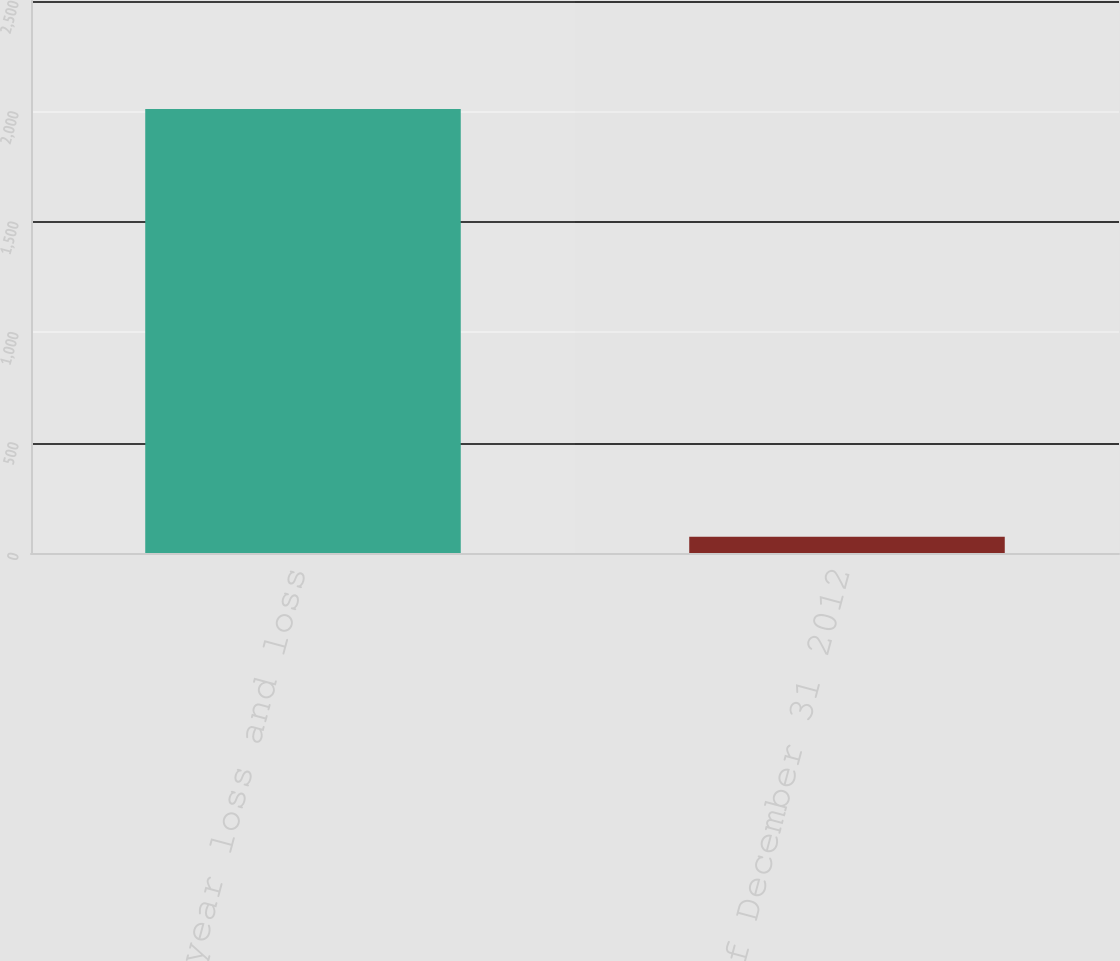<chart> <loc_0><loc_0><loc_500><loc_500><bar_chart><fcel>Accident year loss and loss<fcel>as of December 31 2012<nl><fcel>2011<fcel>73.6<nl></chart> 